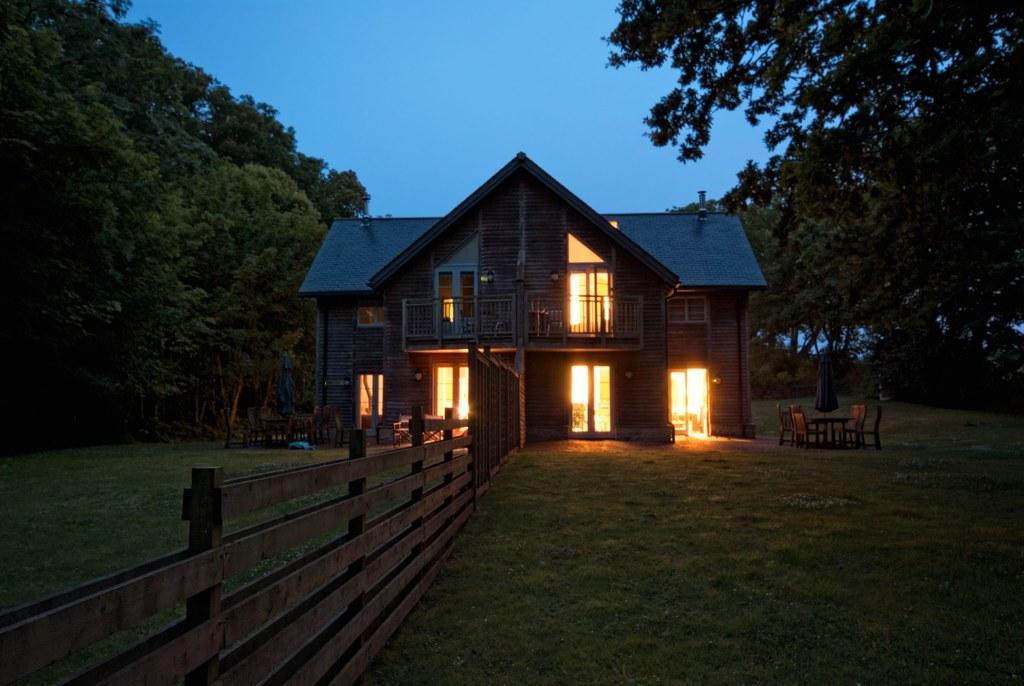Could you give a brief overview of what you see in this image? In the image there is a wooden house and there is a fencing that is separating the houses into two parts and there are two dining tables in front of the houses and around the houses there is a beautiful garden with plenty of trees. 